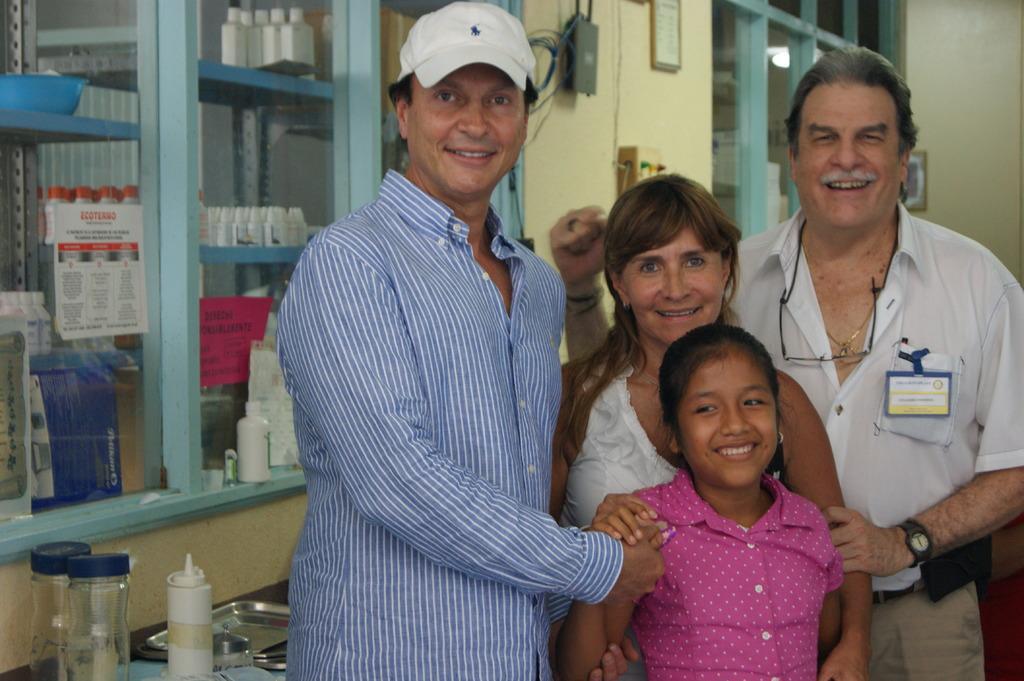Describe this image in one or two sentences. In the center of the image we can see some persons are standing and smiling. In the background of the image we can see racks, bottles, papers, bowl, photo frames, wall, board and light. At the bottom of the image we can see a table. On the table we can see jars, bottles and some vessels. 